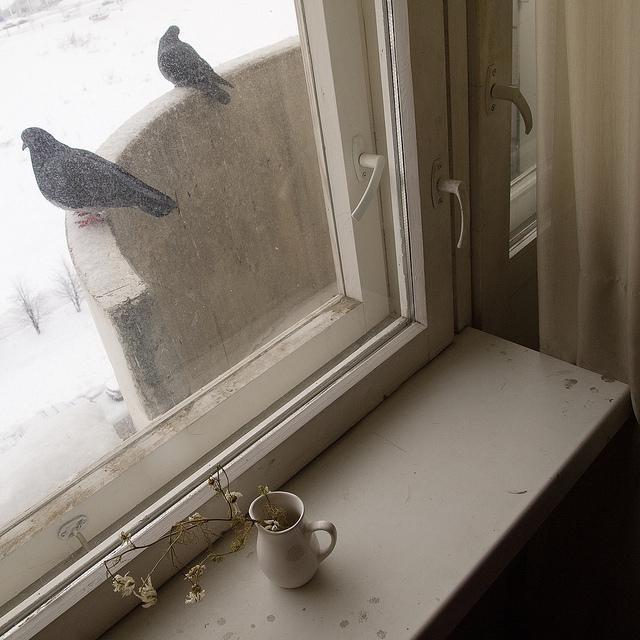How many birds are in the photo?
Give a very brief answer. 2. How many birds are visible?
Give a very brief answer. 2. 